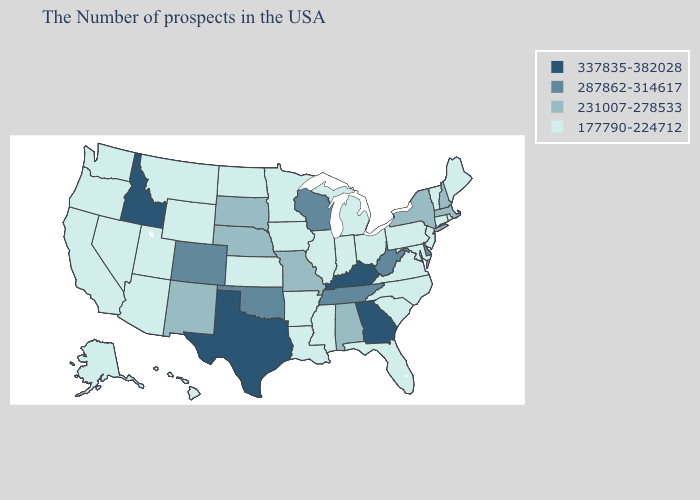Name the states that have a value in the range 287862-314617?
Concise answer only. Delaware, West Virginia, Tennessee, Wisconsin, Oklahoma, Colorado. What is the highest value in the Northeast ?
Give a very brief answer. 231007-278533. Which states have the highest value in the USA?
Write a very short answer. Georgia, Kentucky, Texas, Idaho. Among the states that border Tennessee , does Georgia have the highest value?
Concise answer only. Yes. Name the states that have a value in the range 287862-314617?
Quick response, please. Delaware, West Virginia, Tennessee, Wisconsin, Oklahoma, Colorado. Does Rhode Island have a lower value than Massachusetts?
Answer briefly. Yes. What is the lowest value in the South?
Give a very brief answer. 177790-224712. Among the states that border New Mexico , which have the lowest value?
Short answer required. Utah, Arizona. Name the states that have a value in the range 177790-224712?
Short answer required. Maine, Rhode Island, Vermont, Connecticut, New Jersey, Maryland, Pennsylvania, Virginia, North Carolina, South Carolina, Ohio, Florida, Michigan, Indiana, Illinois, Mississippi, Louisiana, Arkansas, Minnesota, Iowa, Kansas, North Dakota, Wyoming, Utah, Montana, Arizona, Nevada, California, Washington, Oregon, Alaska, Hawaii. Name the states that have a value in the range 287862-314617?
Quick response, please. Delaware, West Virginia, Tennessee, Wisconsin, Oklahoma, Colorado. Which states have the lowest value in the USA?
Answer briefly. Maine, Rhode Island, Vermont, Connecticut, New Jersey, Maryland, Pennsylvania, Virginia, North Carolina, South Carolina, Ohio, Florida, Michigan, Indiana, Illinois, Mississippi, Louisiana, Arkansas, Minnesota, Iowa, Kansas, North Dakota, Wyoming, Utah, Montana, Arizona, Nevada, California, Washington, Oregon, Alaska, Hawaii. Name the states that have a value in the range 337835-382028?
Write a very short answer. Georgia, Kentucky, Texas, Idaho. Does New York have a lower value than Nebraska?
Concise answer only. No. Which states hav the highest value in the Northeast?
Answer briefly. Massachusetts, New Hampshire, New York. Does North Carolina have the same value as Kentucky?
Give a very brief answer. No. 